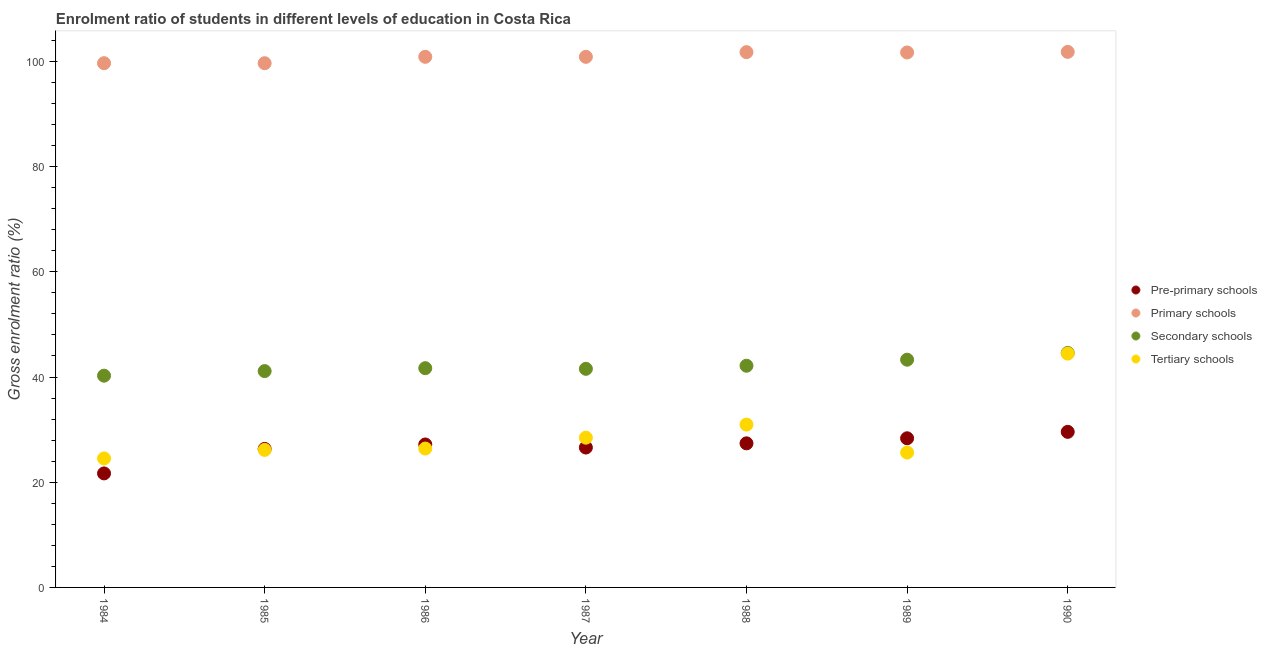How many different coloured dotlines are there?
Your response must be concise. 4. Is the number of dotlines equal to the number of legend labels?
Keep it short and to the point. Yes. What is the gross enrolment ratio in secondary schools in 1989?
Keep it short and to the point. 43.29. Across all years, what is the maximum gross enrolment ratio in primary schools?
Give a very brief answer. 101.81. Across all years, what is the minimum gross enrolment ratio in tertiary schools?
Keep it short and to the point. 24.52. In which year was the gross enrolment ratio in secondary schools maximum?
Your answer should be compact. 1990. What is the total gross enrolment ratio in tertiary schools in the graph?
Your answer should be compact. 206.57. What is the difference between the gross enrolment ratio in pre-primary schools in 1985 and that in 1987?
Your answer should be compact. -0.26. What is the difference between the gross enrolment ratio in secondary schools in 1985 and the gross enrolment ratio in tertiary schools in 1986?
Your response must be concise. 14.73. What is the average gross enrolment ratio in secondary schools per year?
Keep it short and to the point. 42.09. In the year 1987, what is the difference between the gross enrolment ratio in tertiary schools and gross enrolment ratio in pre-primary schools?
Ensure brevity in your answer.  1.87. In how many years, is the gross enrolment ratio in secondary schools greater than 44 %?
Provide a short and direct response. 1. What is the ratio of the gross enrolment ratio in secondary schools in 1984 to that in 1985?
Keep it short and to the point. 0.98. Is the difference between the gross enrolment ratio in tertiary schools in 1987 and 1988 greater than the difference between the gross enrolment ratio in pre-primary schools in 1987 and 1988?
Your response must be concise. No. What is the difference between the highest and the second highest gross enrolment ratio in primary schools?
Offer a terse response. 0.05. What is the difference between the highest and the lowest gross enrolment ratio in pre-primary schools?
Make the answer very short. 7.9. In how many years, is the gross enrolment ratio in secondary schools greater than the average gross enrolment ratio in secondary schools taken over all years?
Offer a very short reply. 3. Is the gross enrolment ratio in secondary schools strictly greater than the gross enrolment ratio in tertiary schools over the years?
Offer a very short reply. Yes. How many years are there in the graph?
Make the answer very short. 7. Where does the legend appear in the graph?
Provide a succinct answer. Center right. How many legend labels are there?
Your answer should be compact. 4. How are the legend labels stacked?
Your response must be concise. Vertical. What is the title of the graph?
Your response must be concise. Enrolment ratio of students in different levels of education in Costa Rica. What is the label or title of the X-axis?
Provide a succinct answer. Year. What is the Gross enrolment ratio (%) in Pre-primary schools in 1984?
Provide a short and direct response. 21.67. What is the Gross enrolment ratio (%) of Primary schools in 1984?
Offer a very short reply. 99.66. What is the Gross enrolment ratio (%) in Secondary schools in 1984?
Make the answer very short. 40.26. What is the Gross enrolment ratio (%) of Tertiary schools in 1984?
Provide a succinct answer. 24.52. What is the Gross enrolment ratio (%) of Pre-primary schools in 1985?
Make the answer very short. 26.33. What is the Gross enrolment ratio (%) in Primary schools in 1985?
Provide a succinct answer. 99.66. What is the Gross enrolment ratio (%) in Secondary schools in 1985?
Your answer should be very brief. 41.13. What is the Gross enrolment ratio (%) in Tertiary schools in 1985?
Offer a terse response. 26.14. What is the Gross enrolment ratio (%) in Pre-primary schools in 1986?
Make the answer very short. 27.17. What is the Gross enrolment ratio (%) in Primary schools in 1986?
Offer a terse response. 100.87. What is the Gross enrolment ratio (%) of Secondary schools in 1986?
Keep it short and to the point. 41.68. What is the Gross enrolment ratio (%) in Tertiary schools in 1986?
Ensure brevity in your answer.  26.4. What is the Gross enrolment ratio (%) in Pre-primary schools in 1987?
Your answer should be very brief. 26.59. What is the Gross enrolment ratio (%) of Primary schools in 1987?
Make the answer very short. 100.87. What is the Gross enrolment ratio (%) in Secondary schools in 1987?
Offer a terse response. 41.56. What is the Gross enrolment ratio (%) of Tertiary schools in 1987?
Your answer should be very brief. 28.47. What is the Gross enrolment ratio (%) in Pre-primary schools in 1988?
Your answer should be compact. 27.39. What is the Gross enrolment ratio (%) of Primary schools in 1988?
Offer a very short reply. 101.76. What is the Gross enrolment ratio (%) of Secondary schools in 1988?
Keep it short and to the point. 42.14. What is the Gross enrolment ratio (%) in Tertiary schools in 1988?
Provide a succinct answer. 30.95. What is the Gross enrolment ratio (%) of Pre-primary schools in 1989?
Offer a very short reply. 28.35. What is the Gross enrolment ratio (%) in Primary schools in 1989?
Make the answer very short. 101.7. What is the Gross enrolment ratio (%) of Secondary schools in 1989?
Give a very brief answer. 43.29. What is the Gross enrolment ratio (%) of Tertiary schools in 1989?
Your response must be concise. 25.64. What is the Gross enrolment ratio (%) in Pre-primary schools in 1990?
Keep it short and to the point. 29.58. What is the Gross enrolment ratio (%) in Primary schools in 1990?
Keep it short and to the point. 101.81. What is the Gross enrolment ratio (%) in Secondary schools in 1990?
Your answer should be very brief. 44.58. What is the Gross enrolment ratio (%) in Tertiary schools in 1990?
Provide a succinct answer. 44.45. Across all years, what is the maximum Gross enrolment ratio (%) of Pre-primary schools?
Offer a very short reply. 29.58. Across all years, what is the maximum Gross enrolment ratio (%) of Primary schools?
Ensure brevity in your answer.  101.81. Across all years, what is the maximum Gross enrolment ratio (%) in Secondary schools?
Offer a terse response. 44.58. Across all years, what is the maximum Gross enrolment ratio (%) in Tertiary schools?
Your answer should be very brief. 44.45. Across all years, what is the minimum Gross enrolment ratio (%) in Pre-primary schools?
Make the answer very short. 21.67. Across all years, what is the minimum Gross enrolment ratio (%) of Primary schools?
Your response must be concise. 99.66. Across all years, what is the minimum Gross enrolment ratio (%) of Secondary schools?
Keep it short and to the point. 40.26. Across all years, what is the minimum Gross enrolment ratio (%) of Tertiary schools?
Your answer should be compact. 24.52. What is the total Gross enrolment ratio (%) of Pre-primary schools in the graph?
Provide a succinct answer. 187.09. What is the total Gross enrolment ratio (%) of Primary schools in the graph?
Your answer should be very brief. 706.33. What is the total Gross enrolment ratio (%) of Secondary schools in the graph?
Your response must be concise. 294.64. What is the total Gross enrolment ratio (%) of Tertiary schools in the graph?
Make the answer very short. 206.57. What is the difference between the Gross enrolment ratio (%) of Pre-primary schools in 1984 and that in 1985?
Your response must be concise. -4.66. What is the difference between the Gross enrolment ratio (%) in Primary schools in 1984 and that in 1985?
Ensure brevity in your answer.  0. What is the difference between the Gross enrolment ratio (%) of Secondary schools in 1984 and that in 1985?
Your response must be concise. -0.87. What is the difference between the Gross enrolment ratio (%) of Tertiary schools in 1984 and that in 1985?
Your answer should be compact. -1.62. What is the difference between the Gross enrolment ratio (%) in Pre-primary schools in 1984 and that in 1986?
Offer a terse response. -5.5. What is the difference between the Gross enrolment ratio (%) in Primary schools in 1984 and that in 1986?
Give a very brief answer. -1.21. What is the difference between the Gross enrolment ratio (%) of Secondary schools in 1984 and that in 1986?
Keep it short and to the point. -1.43. What is the difference between the Gross enrolment ratio (%) in Tertiary schools in 1984 and that in 1986?
Ensure brevity in your answer.  -1.88. What is the difference between the Gross enrolment ratio (%) in Pre-primary schools in 1984 and that in 1987?
Keep it short and to the point. -4.92. What is the difference between the Gross enrolment ratio (%) of Primary schools in 1984 and that in 1987?
Make the answer very short. -1.21. What is the difference between the Gross enrolment ratio (%) in Secondary schools in 1984 and that in 1987?
Make the answer very short. -1.3. What is the difference between the Gross enrolment ratio (%) of Tertiary schools in 1984 and that in 1987?
Your response must be concise. -3.94. What is the difference between the Gross enrolment ratio (%) of Pre-primary schools in 1984 and that in 1988?
Offer a very short reply. -5.72. What is the difference between the Gross enrolment ratio (%) in Primary schools in 1984 and that in 1988?
Your answer should be compact. -2.1. What is the difference between the Gross enrolment ratio (%) of Secondary schools in 1984 and that in 1988?
Provide a short and direct response. -1.89. What is the difference between the Gross enrolment ratio (%) in Tertiary schools in 1984 and that in 1988?
Offer a very short reply. -6.43. What is the difference between the Gross enrolment ratio (%) in Pre-primary schools in 1984 and that in 1989?
Ensure brevity in your answer.  -6.68. What is the difference between the Gross enrolment ratio (%) of Primary schools in 1984 and that in 1989?
Provide a short and direct response. -2.04. What is the difference between the Gross enrolment ratio (%) of Secondary schools in 1984 and that in 1989?
Offer a terse response. -3.04. What is the difference between the Gross enrolment ratio (%) in Tertiary schools in 1984 and that in 1989?
Make the answer very short. -1.12. What is the difference between the Gross enrolment ratio (%) in Pre-primary schools in 1984 and that in 1990?
Make the answer very short. -7.9. What is the difference between the Gross enrolment ratio (%) in Primary schools in 1984 and that in 1990?
Provide a succinct answer. -2.15. What is the difference between the Gross enrolment ratio (%) in Secondary schools in 1984 and that in 1990?
Offer a very short reply. -4.33. What is the difference between the Gross enrolment ratio (%) of Tertiary schools in 1984 and that in 1990?
Your response must be concise. -19.93. What is the difference between the Gross enrolment ratio (%) in Pre-primary schools in 1985 and that in 1986?
Ensure brevity in your answer.  -0.84. What is the difference between the Gross enrolment ratio (%) in Primary schools in 1985 and that in 1986?
Offer a terse response. -1.21. What is the difference between the Gross enrolment ratio (%) in Secondary schools in 1985 and that in 1986?
Keep it short and to the point. -0.56. What is the difference between the Gross enrolment ratio (%) in Tertiary schools in 1985 and that in 1986?
Provide a short and direct response. -0.26. What is the difference between the Gross enrolment ratio (%) in Pre-primary schools in 1985 and that in 1987?
Your response must be concise. -0.26. What is the difference between the Gross enrolment ratio (%) in Primary schools in 1985 and that in 1987?
Offer a very short reply. -1.21. What is the difference between the Gross enrolment ratio (%) in Secondary schools in 1985 and that in 1987?
Your response must be concise. -0.43. What is the difference between the Gross enrolment ratio (%) of Tertiary schools in 1985 and that in 1987?
Your answer should be compact. -2.32. What is the difference between the Gross enrolment ratio (%) of Pre-primary schools in 1985 and that in 1988?
Offer a terse response. -1.06. What is the difference between the Gross enrolment ratio (%) in Primary schools in 1985 and that in 1988?
Your answer should be very brief. -2.1. What is the difference between the Gross enrolment ratio (%) in Secondary schools in 1985 and that in 1988?
Keep it short and to the point. -1.02. What is the difference between the Gross enrolment ratio (%) of Tertiary schools in 1985 and that in 1988?
Make the answer very short. -4.81. What is the difference between the Gross enrolment ratio (%) of Pre-primary schools in 1985 and that in 1989?
Offer a very short reply. -2.02. What is the difference between the Gross enrolment ratio (%) of Primary schools in 1985 and that in 1989?
Offer a terse response. -2.04. What is the difference between the Gross enrolment ratio (%) of Secondary schools in 1985 and that in 1989?
Your answer should be very brief. -2.17. What is the difference between the Gross enrolment ratio (%) of Tertiary schools in 1985 and that in 1989?
Ensure brevity in your answer.  0.5. What is the difference between the Gross enrolment ratio (%) in Pre-primary schools in 1985 and that in 1990?
Offer a terse response. -3.25. What is the difference between the Gross enrolment ratio (%) of Primary schools in 1985 and that in 1990?
Provide a succinct answer. -2.15. What is the difference between the Gross enrolment ratio (%) in Secondary schools in 1985 and that in 1990?
Your response must be concise. -3.46. What is the difference between the Gross enrolment ratio (%) of Tertiary schools in 1985 and that in 1990?
Provide a short and direct response. -18.31. What is the difference between the Gross enrolment ratio (%) of Pre-primary schools in 1986 and that in 1987?
Make the answer very short. 0.58. What is the difference between the Gross enrolment ratio (%) of Primary schools in 1986 and that in 1987?
Give a very brief answer. 0. What is the difference between the Gross enrolment ratio (%) of Secondary schools in 1986 and that in 1987?
Give a very brief answer. 0.12. What is the difference between the Gross enrolment ratio (%) in Tertiary schools in 1986 and that in 1987?
Make the answer very short. -2.07. What is the difference between the Gross enrolment ratio (%) in Pre-primary schools in 1986 and that in 1988?
Ensure brevity in your answer.  -0.22. What is the difference between the Gross enrolment ratio (%) in Primary schools in 1986 and that in 1988?
Your response must be concise. -0.89. What is the difference between the Gross enrolment ratio (%) of Secondary schools in 1986 and that in 1988?
Your answer should be compact. -0.46. What is the difference between the Gross enrolment ratio (%) in Tertiary schools in 1986 and that in 1988?
Your answer should be compact. -4.55. What is the difference between the Gross enrolment ratio (%) of Pre-primary schools in 1986 and that in 1989?
Offer a terse response. -1.18. What is the difference between the Gross enrolment ratio (%) in Primary schools in 1986 and that in 1989?
Your response must be concise. -0.83. What is the difference between the Gross enrolment ratio (%) of Secondary schools in 1986 and that in 1989?
Make the answer very short. -1.61. What is the difference between the Gross enrolment ratio (%) in Tertiary schools in 1986 and that in 1989?
Give a very brief answer. 0.76. What is the difference between the Gross enrolment ratio (%) of Pre-primary schools in 1986 and that in 1990?
Give a very brief answer. -2.4. What is the difference between the Gross enrolment ratio (%) of Primary schools in 1986 and that in 1990?
Give a very brief answer. -0.94. What is the difference between the Gross enrolment ratio (%) of Secondary schools in 1986 and that in 1990?
Ensure brevity in your answer.  -2.9. What is the difference between the Gross enrolment ratio (%) in Tertiary schools in 1986 and that in 1990?
Your answer should be very brief. -18.05. What is the difference between the Gross enrolment ratio (%) of Pre-primary schools in 1987 and that in 1988?
Provide a short and direct response. -0.8. What is the difference between the Gross enrolment ratio (%) in Primary schools in 1987 and that in 1988?
Your answer should be compact. -0.89. What is the difference between the Gross enrolment ratio (%) in Secondary schools in 1987 and that in 1988?
Offer a very short reply. -0.58. What is the difference between the Gross enrolment ratio (%) of Tertiary schools in 1987 and that in 1988?
Your answer should be very brief. -2.48. What is the difference between the Gross enrolment ratio (%) of Pre-primary schools in 1987 and that in 1989?
Keep it short and to the point. -1.76. What is the difference between the Gross enrolment ratio (%) of Primary schools in 1987 and that in 1989?
Offer a terse response. -0.83. What is the difference between the Gross enrolment ratio (%) in Secondary schools in 1987 and that in 1989?
Ensure brevity in your answer.  -1.74. What is the difference between the Gross enrolment ratio (%) in Tertiary schools in 1987 and that in 1989?
Provide a succinct answer. 2.83. What is the difference between the Gross enrolment ratio (%) of Pre-primary schools in 1987 and that in 1990?
Your response must be concise. -2.98. What is the difference between the Gross enrolment ratio (%) in Primary schools in 1987 and that in 1990?
Your answer should be very brief. -0.94. What is the difference between the Gross enrolment ratio (%) of Secondary schools in 1987 and that in 1990?
Your answer should be very brief. -3.02. What is the difference between the Gross enrolment ratio (%) of Tertiary schools in 1987 and that in 1990?
Provide a short and direct response. -15.98. What is the difference between the Gross enrolment ratio (%) in Pre-primary schools in 1988 and that in 1989?
Give a very brief answer. -0.96. What is the difference between the Gross enrolment ratio (%) of Primary schools in 1988 and that in 1989?
Keep it short and to the point. 0.06. What is the difference between the Gross enrolment ratio (%) in Secondary schools in 1988 and that in 1989?
Keep it short and to the point. -1.15. What is the difference between the Gross enrolment ratio (%) of Tertiary schools in 1988 and that in 1989?
Provide a succinct answer. 5.31. What is the difference between the Gross enrolment ratio (%) in Pre-primary schools in 1988 and that in 1990?
Offer a very short reply. -2.18. What is the difference between the Gross enrolment ratio (%) in Primary schools in 1988 and that in 1990?
Give a very brief answer. -0.05. What is the difference between the Gross enrolment ratio (%) of Secondary schools in 1988 and that in 1990?
Your answer should be compact. -2.44. What is the difference between the Gross enrolment ratio (%) in Tertiary schools in 1988 and that in 1990?
Your answer should be compact. -13.5. What is the difference between the Gross enrolment ratio (%) in Pre-primary schools in 1989 and that in 1990?
Your answer should be very brief. -1.22. What is the difference between the Gross enrolment ratio (%) of Primary schools in 1989 and that in 1990?
Give a very brief answer. -0.11. What is the difference between the Gross enrolment ratio (%) in Secondary schools in 1989 and that in 1990?
Your response must be concise. -1.29. What is the difference between the Gross enrolment ratio (%) of Tertiary schools in 1989 and that in 1990?
Your response must be concise. -18.81. What is the difference between the Gross enrolment ratio (%) in Pre-primary schools in 1984 and the Gross enrolment ratio (%) in Primary schools in 1985?
Offer a terse response. -77.98. What is the difference between the Gross enrolment ratio (%) in Pre-primary schools in 1984 and the Gross enrolment ratio (%) in Secondary schools in 1985?
Give a very brief answer. -19.45. What is the difference between the Gross enrolment ratio (%) in Pre-primary schools in 1984 and the Gross enrolment ratio (%) in Tertiary schools in 1985?
Give a very brief answer. -4.47. What is the difference between the Gross enrolment ratio (%) in Primary schools in 1984 and the Gross enrolment ratio (%) in Secondary schools in 1985?
Make the answer very short. 58.54. What is the difference between the Gross enrolment ratio (%) of Primary schools in 1984 and the Gross enrolment ratio (%) of Tertiary schools in 1985?
Provide a succinct answer. 73.52. What is the difference between the Gross enrolment ratio (%) in Secondary schools in 1984 and the Gross enrolment ratio (%) in Tertiary schools in 1985?
Ensure brevity in your answer.  14.11. What is the difference between the Gross enrolment ratio (%) of Pre-primary schools in 1984 and the Gross enrolment ratio (%) of Primary schools in 1986?
Provide a short and direct response. -79.2. What is the difference between the Gross enrolment ratio (%) of Pre-primary schools in 1984 and the Gross enrolment ratio (%) of Secondary schools in 1986?
Make the answer very short. -20.01. What is the difference between the Gross enrolment ratio (%) of Pre-primary schools in 1984 and the Gross enrolment ratio (%) of Tertiary schools in 1986?
Offer a very short reply. -4.72. What is the difference between the Gross enrolment ratio (%) of Primary schools in 1984 and the Gross enrolment ratio (%) of Secondary schools in 1986?
Your answer should be compact. 57.98. What is the difference between the Gross enrolment ratio (%) of Primary schools in 1984 and the Gross enrolment ratio (%) of Tertiary schools in 1986?
Provide a short and direct response. 73.26. What is the difference between the Gross enrolment ratio (%) of Secondary schools in 1984 and the Gross enrolment ratio (%) of Tertiary schools in 1986?
Offer a terse response. 13.86. What is the difference between the Gross enrolment ratio (%) in Pre-primary schools in 1984 and the Gross enrolment ratio (%) in Primary schools in 1987?
Offer a terse response. -79.2. What is the difference between the Gross enrolment ratio (%) in Pre-primary schools in 1984 and the Gross enrolment ratio (%) in Secondary schools in 1987?
Your response must be concise. -19.88. What is the difference between the Gross enrolment ratio (%) in Pre-primary schools in 1984 and the Gross enrolment ratio (%) in Tertiary schools in 1987?
Provide a succinct answer. -6.79. What is the difference between the Gross enrolment ratio (%) of Primary schools in 1984 and the Gross enrolment ratio (%) of Secondary schools in 1987?
Your answer should be compact. 58.1. What is the difference between the Gross enrolment ratio (%) in Primary schools in 1984 and the Gross enrolment ratio (%) in Tertiary schools in 1987?
Offer a very short reply. 71.19. What is the difference between the Gross enrolment ratio (%) of Secondary schools in 1984 and the Gross enrolment ratio (%) of Tertiary schools in 1987?
Ensure brevity in your answer.  11.79. What is the difference between the Gross enrolment ratio (%) of Pre-primary schools in 1984 and the Gross enrolment ratio (%) of Primary schools in 1988?
Your response must be concise. -80.08. What is the difference between the Gross enrolment ratio (%) in Pre-primary schools in 1984 and the Gross enrolment ratio (%) in Secondary schools in 1988?
Your answer should be compact. -20.47. What is the difference between the Gross enrolment ratio (%) of Pre-primary schools in 1984 and the Gross enrolment ratio (%) of Tertiary schools in 1988?
Your answer should be very brief. -9.28. What is the difference between the Gross enrolment ratio (%) in Primary schools in 1984 and the Gross enrolment ratio (%) in Secondary schools in 1988?
Ensure brevity in your answer.  57.52. What is the difference between the Gross enrolment ratio (%) in Primary schools in 1984 and the Gross enrolment ratio (%) in Tertiary schools in 1988?
Your response must be concise. 68.71. What is the difference between the Gross enrolment ratio (%) of Secondary schools in 1984 and the Gross enrolment ratio (%) of Tertiary schools in 1988?
Your answer should be compact. 9.3. What is the difference between the Gross enrolment ratio (%) in Pre-primary schools in 1984 and the Gross enrolment ratio (%) in Primary schools in 1989?
Offer a very short reply. -80.02. What is the difference between the Gross enrolment ratio (%) of Pre-primary schools in 1984 and the Gross enrolment ratio (%) of Secondary schools in 1989?
Your answer should be very brief. -21.62. What is the difference between the Gross enrolment ratio (%) in Pre-primary schools in 1984 and the Gross enrolment ratio (%) in Tertiary schools in 1989?
Keep it short and to the point. -3.96. What is the difference between the Gross enrolment ratio (%) of Primary schools in 1984 and the Gross enrolment ratio (%) of Secondary schools in 1989?
Provide a short and direct response. 56.37. What is the difference between the Gross enrolment ratio (%) of Primary schools in 1984 and the Gross enrolment ratio (%) of Tertiary schools in 1989?
Ensure brevity in your answer.  74.02. What is the difference between the Gross enrolment ratio (%) of Secondary schools in 1984 and the Gross enrolment ratio (%) of Tertiary schools in 1989?
Keep it short and to the point. 14.62. What is the difference between the Gross enrolment ratio (%) in Pre-primary schools in 1984 and the Gross enrolment ratio (%) in Primary schools in 1990?
Offer a terse response. -80.13. What is the difference between the Gross enrolment ratio (%) in Pre-primary schools in 1984 and the Gross enrolment ratio (%) in Secondary schools in 1990?
Keep it short and to the point. -22.91. What is the difference between the Gross enrolment ratio (%) of Pre-primary schools in 1984 and the Gross enrolment ratio (%) of Tertiary schools in 1990?
Provide a short and direct response. -22.78. What is the difference between the Gross enrolment ratio (%) in Primary schools in 1984 and the Gross enrolment ratio (%) in Secondary schools in 1990?
Your response must be concise. 55.08. What is the difference between the Gross enrolment ratio (%) in Primary schools in 1984 and the Gross enrolment ratio (%) in Tertiary schools in 1990?
Ensure brevity in your answer.  55.21. What is the difference between the Gross enrolment ratio (%) of Secondary schools in 1984 and the Gross enrolment ratio (%) of Tertiary schools in 1990?
Ensure brevity in your answer.  -4.19. What is the difference between the Gross enrolment ratio (%) in Pre-primary schools in 1985 and the Gross enrolment ratio (%) in Primary schools in 1986?
Offer a terse response. -74.54. What is the difference between the Gross enrolment ratio (%) of Pre-primary schools in 1985 and the Gross enrolment ratio (%) of Secondary schools in 1986?
Your response must be concise. -15.35. What is the difference between the Gross enrolment ratio (%) in Pre-primary schools in 1985 and the Gross enrolment ratio (%) in Tertiary schools in 1986?
Provide a succinct answer. -0.07. What is the difference between the Gross enrolment ratio (%) of Primary schools in 1985 and the Gross enrolment ratio (%) of Secondary schools in 1986?
Your answer should be very brief. 57.98. What is the difference between the Gross enrolment ratio (%) of Primary schools in 1985 and the Gross enrolment ratio (%) of Tertiary schools in 1986?
Give a very brief answer. 73.26. What is the difference between the Gross enrolment ratio (%) of Secondary schools in 1985 and the Gross enrolment ratio (%) of Tertiary schools in 1986?
Your response must be concise. 14.73. What is the difference between the Gross enrolment ratio (%) of Pre-primary schools in 1985 and the Gross enrolment ratio (%) of Primary schools in 1987?
Ensure brevity in your answer.  -74.54. What is the difference between the Gross enrolment ratio (%) in Pre-primary schools in 1985 and the Gross enrolment ratio (%) in Secondary schools in 1987?
Ensure brevity in your answer.  -15.23. What is the difference between the Gross enrolment ratio (%) in Pre-primary schools in 1985 and the Gross enrolment ratio (%) in Tertiary schools in 1987?
Provide a short and direct response. -2.14. What is the difference between the Gross enrolment ratio (%) in Primary schools in 1985 and the Gross enrolment ratio (%) in Secondary schools in 1987?
Give a very brief answer. 58.1. What is the difference between the Gross enrolment ratio (%) of Primary schools in 1985 and the Gross enrolment ratio (%) of Tertiary schools in 1987?
Provide a short and direct response. 71.19. What is the difference between the Gross enrolment ratio (%) in Secondary schools in 1985 and the Gross enrolment ratio (%) in Tertiary schools in 1987?
Provide a succinct answer. 12.66. What is the difference between the Gross enrolment ratio (%) of Pre-primary schools in 1985 and the Gross enrolment ratio (%) of Primary schools in 1988?
Ensure brevity in your answer.  -75.43. What is the difference between the Gross enrolment ratio (%) in Pre-primary schools in 1985 and the Gross enrolment ratio (%) in Secondary schools in 1988?
Your response must be concise. -15.81. What is the difference between the Gross enrolment ratio (%) in Pre-primary schools in 1985 and the Gross enrolment ratio (%) in Tertiary schools in 1988?
Give a very brief answer. -4.62. What is the difference between the Gross enrolment ratio (%) of Primary schools in 1985 and the Gross enrolment ratio (%) of Secondary schools in 1988?
Your answer should be compact. 57.52. What is the difference between the Gross enrolment ratio (%) of Primary schools in 1985 and the Gross enrolment ratio (%) of Tertiary schools in 1988?
Your answer should be very brief. 68.71. What is the difference between the Gross enrolment ratio (%) of Secondary schools in 1985 and the Gross enrolment ratio (%) of Tertiary schools in 1988?
Provide a short and direct response. 10.17. What is the difference between the Gross enrolment ratio (%) in Pre-primary schools in 1985 and the Gross enrolment ratio (%) in Primary schools in 1989?
Your response must be concise. -75.37. What is the difference between the Gross enrolment ratio (%) in Pre-primary schools in 1985 and the Gross enrolment ratio (%) in Secondary schools in 1989?
Provide a short and direct response. -16.96. What is the difference between the Gross enrolment ratio (%) in Pre-primary schools in 1985 and the Gross enrolment ratio (%) in Tertiary schools in 1989?
Give a very brief answer. 0.69. What is the difference between the Gross enrolment ratio (%) in Primary schools in 1985 and the Gross enrolment ratio (%) in Secondary schools in 1989?
Your response must be concise. 56.37. What is the difference between the Gross enrolment ratio (%) in Primary schools in 1985 and the Gross enrolment ratio (%) in Tertiary schools in 1989?
Your answer should be compact. 74.02. What is the difference between the Gross enrolment ratio (%) in Secondary schools in 1985 and the Gross enrolment ratio (%) in Tertiary schools in 1989?
Your response must be concise. 15.49. What is the difference between the Gross enrolment ratio (%) of Pre-primary schools in 1985 and the Gross enrolment ratio (%) of Primary schools in 1990?
Offer a very short reply. -75.48. What is the difference between the Gross enrolment ratio (%) in Pre-primary schools in 1985 and the Gross enrolment ratio (%) in Secondary schools in 1990?
Your response must be concise. -18.25. What is the difference between the Gross enrolment ratio (%) in Pre-primary schools in 1985 and the Gross enrolment ratio (%) in Tertiary schools in 1990?
Ensure brevity in your answer.  -18.12. What is the difference between the Gross enrolment ratio (%) in Primary schools in 1985 and the Gross enrolment ratio (%) in Secondary schools in 1990?
Give a very brief answer. 55.08. What is the difference between the Gross enrolment ratio (%) in Primary schools in 1985 and the Gross enrolment ratio (%) in Tertiary schools in 1990?
Ensure brevity in your answer.  55.21. What is the difference between the Gross enrolment ratio (%) in Secondary schools in 1985 and the Gross enrolment ratio (%) in Tertiary schools in 1990?
Your answer should be very brief. -3.33. What is the difference between the Gross enrolment ratio (%) of Pre-primary schools in 1986 and the Gross enrolment ratio (%) of Primary schools in 1987?
Give a very brief answer. -73.7. What is the difference between the Gross enrolment ratio (%) of Pre-primary schools in 1986 and the Gross enrolment ratio (%) of Secondary schools in 1987?
Provide a short and direct response. -14.38. What is the difference between the Gross enrolment ratio (%) of Pre-primary schools in 1986 and the Gross enrolment ratio (%) of Tertiary schools in 1987?
Offer a very short reply. -1.29. What is the difference between the Gross enrolment ratio (%) in Primary schools in 1986 and the Gross enrolment ratio (%) in Secondary schools in 1987?
Make the answer very short. 59.31. What is the difference between the Gross enrolment ratio (%) of Primary schools in 1986 and the Gross enrolment ratio (%) of Tertiary schools in 1987?
Ensure brevity in your answer.  72.4. What is the difference between the Gross enrolment ratio (%) in Secondary schools in 1986 and the Gross enrolment ratio (%) in Tertiary schools in 1987?
Ensure brevity in your answer.  13.21. What is the difference between the Gross enrolment ratio (%) of Pre-primary schools in 1986 and the Gross enrolment ratio (%) of Primary schools in 1988?
Offer a terse response. -74.58. What is the difference between the Gross enrolment ratio (%) of Pre-primary schools in 1986 and the Gross enrolment ratio (%) of Secondary schools in 1988?
Make the answer very short. -14.97. What is the difference between the Gross enrolment ratio (%) of Pre-primary schools in 1986 and the Gross enrolment ratio (%) of Tertiary schools in 1988?
Your answer should be very brief. -3.78. What is the difference between the Gross enrolment ratio (%) of Primary schools in 1986 and the Gross enrolment ratio (%) of Secondary schools in 1988?
Your response must be concise. 58.73. What is the difference between the Gross enrolment ratio (%) of Primary schools in 1986 and the Gross enrolment ratio (%) of Tertiary schools in 1988?
Your answer should be compact. 69.92. What is the difference between the Gross enrolment ratio (%) of Secondary schools in 1986 and the Gross enrolment ratio (%) of Tertiary schools in 1988?
Keep it short and to the point. 10.73. What is the difference between the Gross enrolment ratio (%) of Pre-primary schools in 1986 and the Gross enrolment ratio (%) of Primary schools in 1989?
Make the answer very short. -74.52. What is the difference between the Gross enrolment ratio (%) of Pre-primary schools in 1986 and the Gross enrolment ratio (%) of Secondary schools in 1989?
Your answer should be very brief. -16.12. What is the difference between the Gross enrolment ratio (%) of Pre-primary schools in 1986 and the Gross enrolment ratio (%) of Tertiary schools in 1989?
Offer a very short reply. 1.54. What is the difference between the Gross enrolment ratio (%) of Primary schools in 1986 and the Gross enrolment ratio (%) of Secondary schools in 1989?
Offer a terse response. 57.58. What is the difference between the Gross enrolment ratio (%) of Primary schools in 1986 and the Gross enrolment ratio (%) of Tertiary schools in 1989?
Your response must be concise. 75.23. What is the difference between the Gross enrolment ratio (%) in Secondary schools in 1986 and the Gross enrolment ratio (%) in Tertiary schools in 1989?
Give a very brief answer. 16.04. What is the difference between the Gross enrolment ratio (%) of Pre-primary schools in 1986 and the Gross enrolment ratio (%) of Primary schools in 1990?
Your answer should be compact. -74.63. What is the difference between the Gross enrolment ratio (%) in Pre-primary schools in 1986 and the Gross enrolment ratio (%) in Secondary schools in 1990?
Your answer should be very brief. -17.41. What is the difference between the Gross enrolment ratio (%) of Pre-primary schools in 1986 and the Gross enrolment ratio (%) of Tertiary schools in 1990?
Your answer should be very brief. -17.28. What is the difference between the Gross enrolment ratio (%) of Primary schools in 1986 and the Gross enrolment ratio (%) of Secondary schools in 1990?
Your response must be concise. 56.29. What is the difference between the Gross enrolment ratio (%) in Primary schools in 1986 and the Gross enrolment ratio (%) in Tertiary schools in 1990?
Ensure brevity in your answer.  56.42. What is the difference between the Gross enrolment ratio (%) of Secondary schools in 1986 and the Gross enrolment ratio (%) of Tertiary schools in 1990?
Make the answer very short. -2.77. What is the difference between the Gross enrolment ratio (%) of Pre-primary schools in 1987 and the Gross enrolment ratio (%) of Primary schools in 1988?
Provide a succinct answer. -75.17. What is the difference between the Gross enrolment ratio (%) of Pre-primary schools in 1987 and the Gross enrolment ratio (%) of Secondary schools in 1988?
Provide a succinct answer. -15.55. What is the difference between the Gross enrolment ratio (%) of Pre-primary schools in 1987 and the Gross enrolment ratio (%) of Tertiary schools in 1988?
Your answer should be very brief. -4.36. What is the difference between the Gross enrolment ratio (%) of Primary schools in 1987 and the Gross enrolment ratio (%) of Secondary schools in 1988?
Your answer should be very brief. 58.73. What is the difference between the Gross enrolment ratio (%) in Primary schools in 1987 and the Gross enrolment ratio (%) in Tertiary schools in 1988?
Offer a terse response. 69.92. What is the difference between the Gross enrolment ratio (%) in Secondary schools in 1987 and the Gross enrolment ratio (%) in Tertiary schools in 1988?
Your answer should be compact. 10.61. What is the difference between the Gross enrolment ratio (%) in Pre-primary schools in 1987 and the Gross enrolment ratio (%) in Primary schools in 1989?
Provide a succinct answer. -75.11. What is the difference between the Gross enrolment ratio (%) in Pre-primary schools in 1987 and the Gross enrolment ratio (%) in Secondary schools in 1989?
Offer a terse response. -16.7. What is the difference between the Gross enrolment ratio (%) of Pre-primary schools in 1987 and the Gross enrolment ratio (%) of Tertiary schools in 1989?
Your answer should be compact. 0.95. What is the difference between the Gross enrolment ratio (%) of Primary schools in 1987 and the Gross enrolment ratio (%) of Secondary schools in 1989?
Offer a very short reply. 57.58. What is the difference between the Gross enrolment ratio (%) in Primary schools in 1987 and the Gross enrolment ratio (%) in Tertiary schools in 1989?
Offer a very short reply. 75.23. What is the difference between the Gross enrolment ratio (%) of Secondary schools in 1987 and the Gross enrolment ratio (%) of Tertiary schools in 1989?
Make the answer very short. 15.92. What is the difference between the Gross enrolment ratio (%) in Pre-primary schools in 1987 and the Gross enrolment ratio (%) in Primary schools in 1990?
Your response must be concise. -75.21. What is the difference between the Gross enrolment ratio (%) of Pre-primary schools in 1987 and the Gross enrolment ratio (%) of Secondary schools in 1990?
Your answer should be compact. -17.99. What is the difference between the Gross enrolment ratio (%) in Pre-primary schools in 1987 and the Gross enrolment ratio (%) in Tertiary schools in 1990?
Make the answer very short. -17.86. What is the difference between the Gross enrolment ratio (%) in Primary schools in 1987 and the Gross enrolment ratio (%) in Secondary schools in 1990?
Provide a short and direct response. 56.29. What is the difference between the Gross enrolment ratio (%) in Primary schools in 1987 and the Gross enrolment ratio (%) in Tertiary schools in 1990?
Ensure brevity in your answer.  56.42. What is the difference between the Gross enrolment ratio (%) in Secondary schools in 1987 and the Gross enrolment ratio (%) in Tertiary schools in 1990?
Offer a terse response. -2.89. What is the difference between the Gross enrolment ratio (%) of Pre-primary schools in 1988 and the Gross enrolment ratio (%) of Primary schools in 1989?
Give a very brief answer. -74.31. What is the difference between the Gross enrolment ratio (%) in Pre-primary schools in 1988 and the Gross enrolment ratio (%) in Secondary schools in 1989?
Ensure brevity in your answer.  -15.9. What is the difference between the Gross enrolment ratio (%) in Pre-primary schools in 1988 and the Gross enrolment ratio (%) in Tertiary schools in 1989?
Ensure brevity in your answer.  1.75. What is the difference between the Gross enrolment ratio (%) in Primary schools in 1988 and the Gross enrolment ratio (%) in Secondary schools in 1989?
Keep it short and to the point. 58.46. What is the difference between the Gross enrolment ratio (%) in Primary schools in 1988 and the Gross enrolment ratio (%) in Tertiary schools in 1989?
Your answer should be very brief. 76.12. What is the difference between the Gross enrolment ratio (%) of Secondary schools in 1988 and the Gross enrolment ratio (%) of Tertiary schools in 1989?
Offer a terse response. 16.5. What is the difference between the Gross enrolment ratio (%) in Pre-primary schools in 1988 and the Gross enrolment ratio (%) in Primary schools in 1990?
Offer a terse response. -74.41. What is the difference between the Gross enrolment ratio (%) of Pre-primary schools in 1988 and the Gross enrolment ratio (%) of Secondary schools in 1990?
Offer a terse response. -17.19. What is the difference between the Gross enrolment ratio (%) of Pre-primary schools in 1988 and the Gross enrolment ratio (%) of Tertiary schools in 1990?
Keep it short and to the point. -17.06. What is the difference between the Gross enrolment ratio (%) in Primary schools in 1988 and the Gross enrolment ratio (%) in Secondary schools in 1990?
Offer a very short reply. 57.18. What is the difference between the Gross enrolment ratio (%) in Primary schools in 1988 and the Gross enrolment ratio (%) in Tertiary schools in 1990?
Provide a succinct answer. 57.31. What is the difference between the Gross enrolment ratio (%) in Secondary schools in 1988 and the Gross enrolment ratio (%) in Tertiary schools in 1990?
Provide a short and direct response. -2.31. What is the difference between the Gross enrolment ratio (%) of Pre-primary schools in 1989 and the Gross enrolment ratio (%) of Primary schools in 1990?
Offer a very short reply. -73.45. What is the difference between the Gross enrolment ratio (%) of Pre-primary schools in 1989 and the Gross enrolment ratio (%) of Secondary schools in 1990?
Your answer should be very brief. -16.23. What is the difference between the Gross enrolment ratio (%) of Pre-primary schools in 1989 and the Gross enrolment ratio (%) of Tertiary schools in 1990?
Your response must be concise. -16.1. What is the difference between the Gross enrolment ratio (%) in Primary schools in 1989 and the Gross enrolment ratio (%) in Secondary schools in 1990?
Give a very brief answer. 57.12. What is the difference between the Gross enrolment ratio (%) in Primary schools in 1989 and the Gross enrolment ratio (%) in Tertiary schools in 1990?
Offer a terse response. 57.25. What is the difference between the Gross enrolment ratio (%) in Secondary schools in 1989 and the Gross enrolment ratio (%) in Tertiary schools in 1990?
Your response must be concise. -1.16. What is the average Gross enrolment ratio (%) of Pre-primary schools per year?
Your response must be concise. 26.73. What is the average Gross enrolment ratio (%) of Primary schools per year?
Provide a succinct answer. 100.9. What is the average Gross enrolment ratio (%) in Secondary schools per year?
Your response must be concise. 42.09. What is the average Gross enrolment ratio (%) in Tertiary schools per year?
Your response must be concise. 29.51. In the year 1984, what is the difference between the Gross enrolment ratio (%) in Pre-primary schools and Gross enrolment ratio (%) in Primary schools?
Ensure brevity in your answer.  -77.99. In the year 1984, what is the difference between the Gross enrolment ratio (%) in Pre-primary schools and Gross enrolment ratio (%) in Secondary schools?
Give a very brief answer. -18.58. In the year 1984, what is the difference between the Gross enrolment ratio (%) of Pre-primary schools and Gross enrolment ratio (%) of Tertiary schools?
Provide a short and direct response. -2.85. In the year 1984, what is the difference between the Gross enrolment ratio (%) in Primary schools and Gross enrolment ratio (%) in Secondary schools?
Offer a very short reply. 59.41. In the year 1984, what is the difference between the Gross enrolment ratio (%) of Primary schools and Gross enrolment ratio (%) of Tertiary schools?
Offer a very short reply. 75.14. In the year 1984, what is the difference between the Gross enrolment ratio (%) in Secondary schools and Gross enrolment ratio (%) in Tertiary schools?
Your answer should be very brief. 15.73. In the year 1985, what is the difference between the Gross enrolment ratio (%) of Pre-primary schools and Gross enrolment ratio (%) of Primary schools?
Keep it short and to the point. -73.33. In the year 1985, what is the difference between the Gross enrolment ratio (%) in Pre-primary schools and Gross enrolment ratio (%) in Secondary schools?
Make the answer very short. -14.79. In the year 1985, what is the difference between the Gross enrolment ratio (%) of Pre-primary schools and Gross enrolment ratio (%) of Tertiary schools?
Offer a terse response. 0.19. In the year 1985, what is the difference between the Gross enrolment ratio (%) of Primary schools and Gross enrolment ratio (%) of Secondary schools?
Provide a succinct answer. 58.53. In the year 1985, what is the difference between the Gross enrolment ratio (%) in Primary schools and Gross enrolment ratio (%) in Tertiary schools?
Make the answer very short. 73.52. In the year 1985, what is the difference between the Gross enrolment ratio (%) in Secondary schools and Gross enrolment ratio (%) in Tertiary schools?
Your answer should be compact. 14.98. In the year 1986, what is the difference between the Gross enrolment ratio (%) in Pre-primary schools and Gross enrolment ratio (%) in Primary schools?
Offer a terse response. -73.7. In the year 1986, what is the difference between the Gross enrolment ratio (%) in Pre-primary schools and Gross enrolment ratio (%) in Secondary schools?
Your answer should be compact. -14.51. In the year 1986, what is the difference between the Gross enrolment ratio (%) of Pre-primary schools and Gross enrolment ratio (%) of Tertiary schools?
Provide a succinct answer. 0.78. In the year 1986, what is the difference between the Gross enrolment ratio (%) of Primary schools and Gross enrolment ratio (%) of Secondary schools?
Make the answer very short. 59.19. In the year 1986, what is the difference between the Gross enrolment ratio (%) of Primary schools and Gross enrolment ratio (%) of Tertiary schools?
Make the answer very short. 74.47. In the year 1986, what is the difference between the Gross enrolment ratio (%) in Secondary schools and Gross enrolment ratio (%) in Tertiary schools?
Give a very brief answer. 15.28. In the year 1987, what is the difference between the Gross enrolment ratio (%) in Pre-primary schools and Gross enrolment ratio (%) in Primary schools?
Make the answer very short. -74.28. In the year 1987, what is the difference between the Gross enrolment ratio (%) of Pre-primary schools and Gross enrolment ratio (%) of Secondary schools?
Your answer should be very brief. -14.97. In the year 1987, what is the difference between the Gross enrolment ratio (%) of Pre-primary schools and Gross enrolment ratio (%) of Tertiary schools?
Your answer should be compact. -1.87. In the year 1987, what is the difference between the Gross enrolment ratio (%) in Primary schools and Gross enrolment ratio (%) in Secondary schools?
Make the answer very short. 59.31. In the year 1987, what is the difference between the Gross enrolment ratio (%) in Primary schools and Gross enrolment ratio (%) in Tertiary schools?
Your answer should be very brief. 72.4. In the year 1987, what is the difference between the Gross enrolment ratio (%) in Secondary schools and Gross enrolment ratio (%) in Tertiary schools?
Your answer should be very brief. 13.09. In the year 1988, what is the difference between the Gross enrolment ratio (%) of Pre-primary schools and Gross enrolment ratio (%) of Primary schools?
Give a very brief answer. -74.37. In the year 1988, what is the difference between the Gross enrolment ratio (%) in Pre-primary schools and Gross enrolment ratio (%) in Secondary schools?
Keep it short and to the point. -14.75. In the year 1988, what is the difference between the Gross enrolment ratio (%) in Pre-primary schools and Gross enrolment ratio (%) in Tertiary schools?
Offer a terse response. -3.56. In the year 1988, what is the difference between the Gross enrolment ratio (%) in Primary schools and Gross enrolment ratio (%) in Secondary schools?
Your answer should be very brief. 59.62. In the year 1988, what is the difference between the Gross enrolment ratio (%) of Primary schools and Gross enrolment ratio (%) of Tertiary schools?
Keep it short and to the point. 70.81. In the year 1988, what is the difference between the Gross enrolment ratio (%) of Secondary schools and Gross enrolment ratio (%) of Tertiary schools?
Your answer should be very brief. 11.19. In the year 1989, what is the difference between the Gross enrolment ratio (%) of Pre-primary schools and Gross enrolment ratio (%) of Primary schools?
Provide a short and direct response. -73.35. In the year 1989, what is the difference between the Gross enrolment ratio (%) of Pre-primary schools and Gross enrolment ratio (%) of Secondary schools?
Your answer should be compact. -14.94. In the year 1989, what is the difference between the Gross enrolment ratio (%) of Pre-primary schools and Gross enrolment ratio (%) of Tertiary schools?
Provide a succinct answer. 2.71. In the year 1989, what is the difference between the Gross enrolment ratio (%) in Primary schools and Gross enrolment ratio (%) in Secondary schools?
Keep it short and to the point. 58.41. In the year 1989, what is the difference between the Gross enrolment ratio (%) of Primary schools and Gross enrolment ratio (%) of Tertiary schools?
Make the answer very short. 76.06. In the year 1989, what is the difference between the Gross enrolment ratio (%) of Secondary schools and Gross enrolment ratio (%) of Tertiary schools?
Give a very brief answer. 17.65. In the year 1990, what is the difference between the Gross enrolment ratio (%) in Pre-primary schools and Gross enrolment ratio (%) in Primary schools?
Offer a very short reply. -72.23. In the year 1990, what is the difference between the Gross enrolment ratio (%) of Pre-primary schools and Gross enrolment ratio (%) of Secondary schools?
Ensure brevity in your answer.  -15.01. In the year 1990, what is the difference between the Gross enrolment ratio (%) in Pre-primary schools and Gross enrolment ratio (%) in Tertiary schools?
Make the answer very short. -14.88. In the year 1990, what is the difference between the Gross enrolment ratio (%) in Primary schools and Gross enrolment ratio (%) in Secondary schools?
Your answer should be compact. 57.23. In the year 1990, what is the difference between the Gross enrolment ratio (%) in Primary schools and Gross enrolment ratio (%) in Tertiary schools?
Offer a very short reply. 57.36. In the year 1990, what is the difference between the Gross enrolment ratio (%) of Secondary schools and Gross enrolment ratio (%) of Tertiary schools?
Keep it short and to the point. 0.13. What is the ratio of the Gross enrolment ratio (%) of Pre-primary schools in 1984 to that in 1985?
Provide a short and direct response. 0.82. What is the ratio of the Gross enrolment ratio (%) in Secondary schools in 1984 to that in 1985?
Make the answer very short. 0.98. What is the ratio of the Gross enrolment ratio (%) of Tertiary schools in 1984 to that in 1985?
Your answer should be very brief. 0.94. What is the ratio of the Gross enrolment ratio (%) of Pre-primary schools in 1984 to that in 1986?
Give a very brief answer. 0.8. What is the ratio of the Gross enrolment ratio (%) in Secondary schools in 1984 to that in 1986?
Your answer should be compact. 0.97. What is the ratio of the Gross enrolment ratio (%) of Tertiary schools in 1984 to that in 1986?
Provide a succinct answer. 0.93. What is the ratio of the Gross enrolment ratio (%) of Pre-primary schools in 1984 to that in 1987?
Provide a succinct answer. 0.82. What is the ratio of the Gross enrolment ratio (%) of Primary schools in 1984 to that in 1987?
Make the answer very short. 0.99. What is the ratio of the Gross enrolment ratio (%) in Secondary schools in 1984 to that in 1987?
Your response must be concise. 0.97. What is the ratio of the Gross enrolment ratio (%) of Tertiary schools in 1984 to that in 1987?
Keep it short and to the point. 0.86. What is the ratio of the Gross enrolment ratio (%) of Pre-primary schools in 1984 to that in 1988?
Make the answer very short. 0.79. What is the ratio of the Gross enrolment ratio (%) of Primary schools in 1984 to that in 1988?
Your response must be concise. 0.98. What is the ratio of the Gross enrolment ratio (%) in Secondary schools in 1984 to that in 1988?
Offer a terse response. 0.96. What is the ratio of the Gross enrolment ratio (%) in Tertiary schools in 1984 to that in 1988?
Offer a terse response. 0.79. What is the ratio of the Gross enrolment ratio (%) in Pre-primary schools in 1984 to that in 1989?
Your response must be concise. 0.76. What is the ratio of the Gross enrolment ratio (%) of Primary schools in 1984 to that in 1989?
Your response must be concise. 0.98. What is the ratio of the Gross enrolment ratio (%) in Secondary schools in 1984 to that in 1989?
Your answer should be compact. 0.93. What is the ratio of the Gross enrolment ratio (%) in Tertiary schools in 1984 to that in 1989?
Your response must be concise. 0.96. What is the ratio of the Gross enrolment ratio (%) of Pre-primary schools in 1984 to that in 1990?
Ensure brevity in your answer.  0.73. What is the ratio of the Gross enrolment ratio (%) of Primary schools in 1984 to that in 1990?
Keep it short and to the point. 0.98. What is the ratio of the Gross enrolment ratio (%) in Secondary schools in 1984 to that in 1990?
Offer a very short reply. 0.9. What is the ratio of the Gross enrolment ratio (%) of Tertiary schools in 1984 to that in 1990?
Keep it short and to the point. 0.55. What is the ratio of the Gross enrolment ratio (%) in Pre-primary schools in 1985 to that in 1986?
Give a very brief answer. 0.97. What is the ratio of the Gross enrolment ratio (%) of Primary schools in 1985 to that in 1986?
Your answer should be very brief. 0.99. What is the ratio of the Gross enrolment ratio (%) of Secondary schools in 1985 to that in 1986?
Provide a succinct answer. 0.99. What is the ratio of the Gross enrolment ratio (%) in Tertiary schools in 1985 to that in 1986?
Your answer should be very brief. 0.99. What is the ratio of the Gross enrolment ratio (%) of Pre-primary schools in 1985 to that in 1987?
Make the answer very short. 0.99. What is the ratio of the Gross enrolment ratio (%) in Tertiary schools in 1985 to that in 1987?
Offer a terse response. 0.92. What is the ratio of the Gross enrolment ratio (%) of Pre-primary schools in 1985 to that in 1988?
Make the answer very short. 0.96. What is the ratio of the Gross enrolment ratio (%) in Primary schools in 1985 to that in 1988?
Offer a terse response. 0.98. What is the ratio of the Gross enrolment ratio (%) of Secondary schools in 1985 to that in 1988?
Give a very brief answer. 0.98. What is the ratio of the Gross enrolment ratio (%) of Tertiary schools in 1985 to that in 1988?
Offer a very short reply. 0.84. What is the ratio of the Gross enrolment ratio (%) in Pre-primary schools in 1985 to that in 1989?
Ensure brevity in your answer.  0.93. What is the ratio of the Gross enrolment ratio (%) in Primary schools in 1985 to that in 1989?
Provide a succinct answer. 0.98. What is the ratio of the Gross enrolment ratio (%) in Secondary schools in 1985 to that in 1989?
Make the answer very short. 0.95. What is the ratio of the Gross enrolment ratio (%) in Tertiary schools in 1985 to that in 1989?
Offer a terse response. 1.02. What is the ratio of the Gross enrolment ratio (%) of Pre-primary schools in 1985 to that in 1990?
Your answer should be very brief. 0.89. What is the ratio of the Gross enrolment ratio (%) of Primary schools in 1985 to that in 1990?
Ensure brevity in your answer.  0.98. What is the ratio of the Gross enrolment ratio (%) of Secondary schools in 1985 to that in 1990?
Make the answer very short. 0.92. What is the ratio of the Gross enrolment ratio (%) in Tertiary schools in 1985 to that in 1990?
Keep it short and to the point. 0.59. What is the ratio of the Gross enrolment ratio (%) in Pre-primary schools in 1986 to that in 1987?
Offer a terse response. 1.02. What is the ratio of the Gross enrolment ratio (%) of Primary schools in 1986 to that in 1987?
Provide a short and direct response. 1. What is the ratio of the Gross enrolment ratio (%) of Tertiary schools in 1986 to that in 1987?
Your response must be concise. 0.93. What is the ratio of the Gross enrolment ratio (%) in Primary schools in 1986 to that in 1988?
Your answer should be compact. 0.99. What is the ratio of the Gross enrolment ratio (%) of Secondary schools in 1986 to that in 1988?
Provide a short and direct response. 0.99. What is the ratio of the Gross enrolment ratio (%) of Tertiary schools in 1986 to that in 1988?
Provide a succinct answer. 0.85. What is the ratio of the Gross enrolment ratio (%) of Pre-primary schools in 1986 to that in 1989?
Provide a succinct answer. 0.96. What is the ratio of the Gross enrolment ratio (%) in Secondary schools in 1986 to that in 1989?
Provide a short and direct response. 0.96. What is the ratio of the Gross enrolment ratio (%) in Tertiary schools in 1986 to that in 1989?
Provide a succinct answer. 1.03. What is the ratio of the Gross enrolment ratio (%) of Pre-primary schools in 1986 to that in 1990?
Offer a very short reply. 0.92. What is the ratio of the Gross enrolment ratio (%) in Primary schools in 1986 to that in 1990?
Your answer should be compact. 0.99. What is the ratio of the Gross enrolment ratio (%) in Secondary schools in 1986 to that in 1990?
Offer a very short reply. 0.93. What is the ratio of the Gross enrolment ratio (%) in Tertiary schools in 1986 to that in 1990?
Ensure brevity in your answer.  0.59. What is the ratio of the Gross enrolment ratio (%) in Pre-primary schools in 1987 to that in 1988?
Make the answer very short. 0.97. What is the ratio of the Gross enrolment ratio (%) of Primary schools in 1987 to that in 1988?
Give a very brief answer. 0.99. What is the ratio of the Gross enrolment ratio (%) in Secondary schools in 1987 to that in 1988?
Ensure brevity in your answer.  0.99. What is the ratio of the Gross enrolment ratio (%) of Tertiary schools in 1987 to that in 1988?
Offer a very short reply. 0.92. What is the ratio of the Gross enrolment ratio (%) in Pre-primary schools in 1987 to that in 1989?
Your response must be concise. 0.94. What is the ratio of the Gross enrolment ratio (%) of Secondary schools in 1987 to that in 1989?
Provide a succinct answer. 0.96. What is the ratio of the Gross enrolment ratio (%) of Tertiary schools in 1987 to that in 1989?
Your response must be concise. 1.11. What is the ratio of the Gross enrolment ratio (%) in Pre-primary schools in 1987 to that in 1990?
Your response must be concise. 0.9. What is the ratio of the Gross enrolment ratio (%) in Primary schools in 1987 to that in 1990?
Your answer should be very brief. 0.99. What is the ratio of the Gross enrolment ratio (%) in Secondary schools in 1987 to that in 1990?
Offer a terse response. 0.93. What is the ratio of the Gross enrolment ratio (%) in Tertiary schools in 1987 to that in 1990?
Provide a short and direct response. 0.64. What is the ratio of the Gross enrolment ratio (%) in Pre-primary schools in 1988 to that in 1989?
Your response must be concise. 0.97. What is the ratio of the Gross enrolment ratio (%) in Primary schools in 1988 to that in 1989?
Provide a short and direct response. 1. What is the ratio of the Gross enrolment ratio (%) of Secondary schools in 1988 to that in 1989?
Provide a succinct answer. 0.97. What is the ratio of the Gross enrolment ratio (%) of Tertiary schools in 1988 to that in 1989?
Your answer should be very brief. 1.21. What is the ratio of the Gross enrolment ratio (%) of Pre-primary schools in 1988 to that in 1990?
Your response must be concise. 0.93. What is the ratio of the Gross enrolment ratio (%) of Secondary schools in 1988 to that in 1990?
Your response must be concise. 0.95. What is the ratio of the Gross enrolment ratio (%) in Tertiary schools in 1988 to that in 1990?
Give a very brief answer. 0.7. What is the ratio of the Gross enrolment ratio (%) in Pre-primary schools in 1989 to that in 1990?
Give a very brief answer. 0.96. What is the ratio of the Gross enrolment ratio (%) of Secondary schools in 1989 to that in 1990?
Your response must be concise. 0.97. What is the ratio of the Gross enrolment ratio (%) of Tertiary schools in 1989 to that in 1990?
Give a very brief answer. 0.58. What is the difference between the highest and the second highest Gross enrolment ratio (%) of Pre-primary schools?
Offer a very short reply. 1.22. What is the difference between the highest and the second highest Gross enrolment ratio (%) of Primary schools?
Ensure brevity in your answer.  0.05. What is the difference between the highest and the second highest Gross enrolment ratio (%) of Secondary schools?
Provide a short and direct response. 1.29. What is the difference between the highest and the second highest Gross enrolment ratio (%) in Tertiary schools?
Your response must be concise. 13.5. What is the difference between the highest and the lowest Gross enrolment ratio (%) of Pre-primary schools?
Make the answer very short. 7.9. What is the difference between the highest and the lowest Gross enrolment ratio (%) in Primary schools?
Offer a terse response. 2.15. What is the difference between the highest and the lowest Gross enrolment ratio (%) of Secondary schools?
Provide a short and direct response. 4.33. What is the difference between the highest and the lowest Gross enrolment ratio (%) in Tertiary schools?
Your answer should be compact. 19.93. 